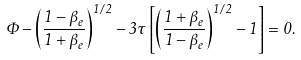<formula> <loc_0><loc_0><loc_500><loc_500>\Phi - \left ( \frac { 1 - \beta _ { e } } { 1 + \beta _ { e } } \right ) ^ { 1 / 2 } - 3 \tau \left [ \left ( \frac { 1 + \beta _ { e } } { 1 - \beta _ { e } } \right ) ^ { 1 / 2 } - 1 \right ] = 0 .</formula> 